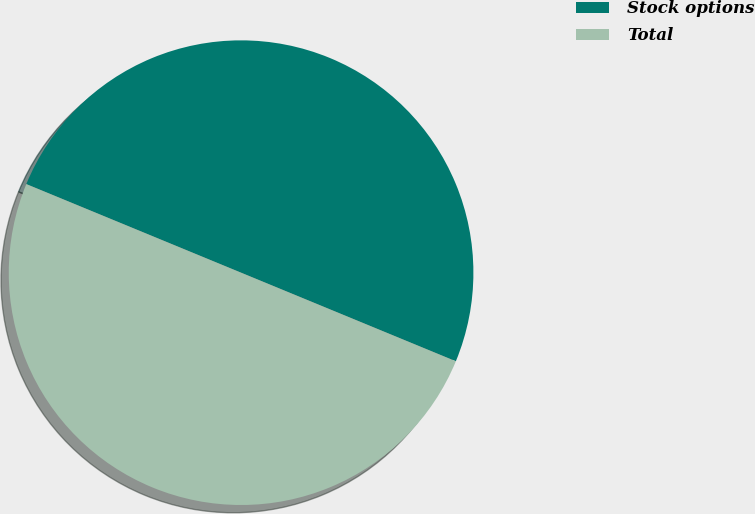Convert chart. <chart><loc_0><loc_0><loc_500><loc_500><pie_chart><fcel>Stock options<fcel>Total<nl><fcel>50.0%<fcel>50.0%<nl></chart> 